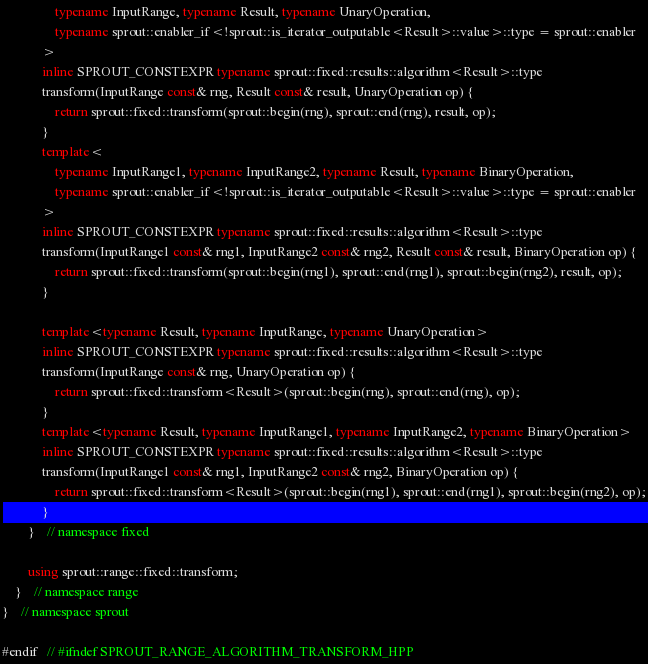<code> <loc_0><loc_0><loc_500><loc_500><_C++_>				typename InputRange, typename Result, typename UnaryOperation,
				typename sprout::enabler_if<!sprout::is_iterator_outputable<Result>::value>::type = sprout::enabler
			>
			inline SPROUT_CONSTEXPR typename sprout::fixed::results::algorithm<Result>::type
			transform(InputRange const& rng, Result const& result, UnaryOperation op) {
				return sprout::fixed::transform(sprout::begin(rng), sprout::end(rng), result, op);
			}
			template<
				typename InputRange1, typename InputRange2, typename Result, typename BinaryOperation,
				typename sprout::enabler_if<!sprout::is_iterator_outputable<Result>::value>::type = sprout::enabler
			>
			inline SPROUT_CONSTEXPR typename sprout::fixed::results::algorithm<Result>::type
			transform(InputRange1 const& rng1, InputRange2 const& rng2, Result const& result, BinaryOperation op) {
				return sprout::fixed::transform(sprout::begin(rng1), sprout::end(rng1), sprout::begin(rng2), result, op);
			}

			template<typename Result, typename InputRange, typename UnaryOperation>
			inline SPROUT_CONSTEXPR typename sprout::fixed::results::algorithm<Result>::type
			transform(InputRange const& rng, UnaryOperation op) {
				return sprout::fixed::transform<Result>(sprout::begin(rng), sprout::end(rng), op);
			}
			template<typename Result, typename InputRange1, typename InputRange2, typename BinaryOperation>
			inline SPROUT_CONSTEXPR typename sprout::fixed::results::algorithm<Result>::type
			transform(InputRange1 const& rng1, InputRange2 const& rng2, BinaryOperation op) {
				return sprout::fixed::transform<Result>(sprout::begin(rng1), sprout::end(rng1), sprout::begin(rng2), op);
			}
		}	// namespace fixed

		using sprout::range::fixed::transform;
	}	// namespace range
}	// namespace sprout

#endif	// #ifndef SPROUT_RANGE_ALGORITHM_TRANSFORM_HPP
</code> 